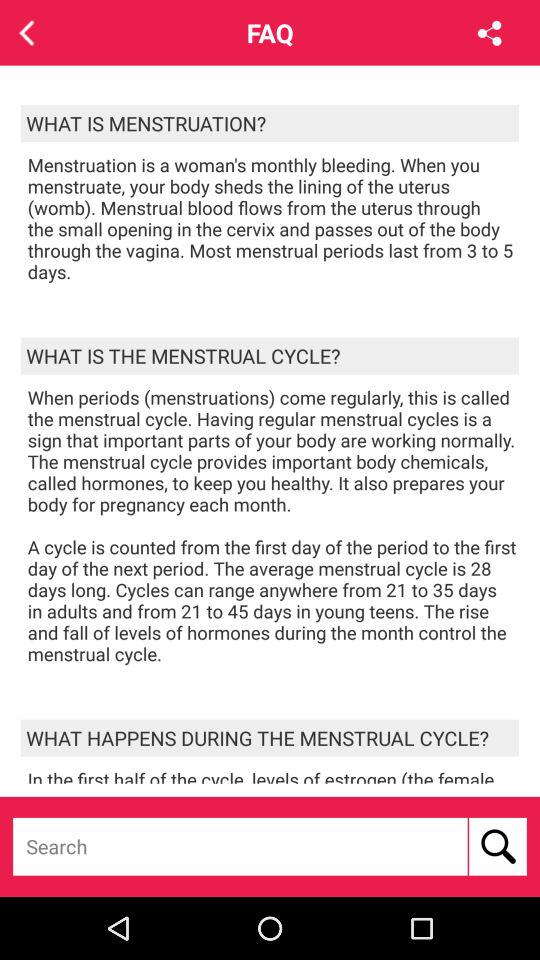What is the menstrual cycle? The menstrual cycle is "When periods (menstruations) come regularly". 